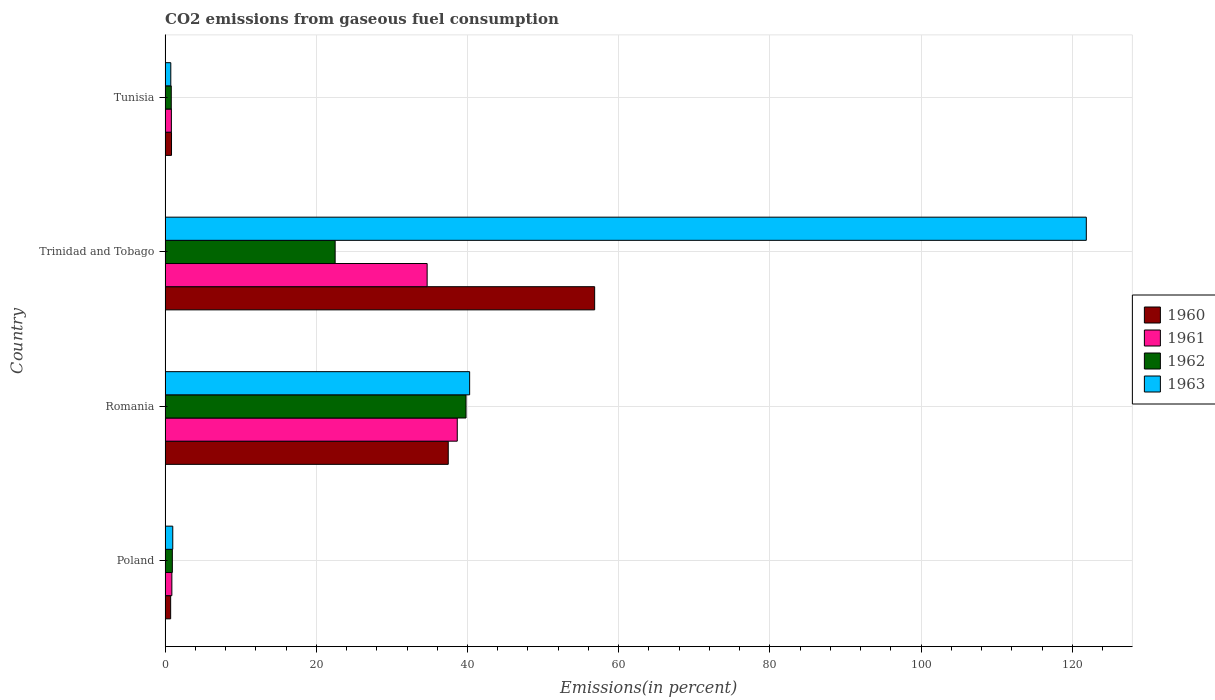How many groups of bars are there?
Your response must be concise. 4. Are the number of bars on each tick of the Y-axis equal?
Ensure brevity in your answer.  Yes. What is the label of the 2nd group of bars from the top?
Make the answer very short. Trinidad and Tobago. In how many cases, is the number of bars for a given country not equal to the number of legend labels?
Your answer should be compact. 0. What is the total CO2 emitted in 1961 in Poland?
Offer a very short reply. 0.89. Across all countries, what is the maximum total CO2 emitted in 1960?
Your response must be concise. 56.82. Across all countries, what is the minimum total CO2 emitted in 1960?
Your response must be concise. 0.74. In which country was the total CO2 emitted in 1960 maximum?
Your answer should be very brief. Trinidad and Tobago. In which country was the total CO2 emitted in 1962 minimum?
Give a very brief answer. Tunisia. What is the total total CO2 emitted in 1962 in the graph?
Offer a terse response. 64.07. What is the difference between the total CO2 emitted in 1963 in Poland and that in Romania?
Your response must be concise. -39.27. What is the difference between the total CO2 emitted in 1962 in Poland and the total CO2 emitted in 1960 in Trinidad and Tobago?
Provide a succinct answer. -55.86. What is the average total CO2 emitted in 1962 per country?
Give a very brief answer. 16.02. What is the difference between the total CO2 emitted in 1961 and total CO2 emitted in 1963 in Tunisia?
Give a very brief answer. 0.08. In how many countries, is the total CO2 emitted in 1962 greater than 92 %?
Provide a succinct answer. 0. What is the ratio of the total CO2 emitted in 1961 in Poland to that in Romania?
Provide a short and direct response. 0.02. Is the total CO2 emitted in 1962 in Poland less than that in Tunisia?
Provide a succinct answer. No. Is the difference between the total CO2 emitted in 1961 in Poland and Trinidad and Tobago greater than the difference between the total CO2 emitted in 1963 in Poland and Trinidad and Tobago?
Your answer should be very brief. Yes. What is the difference between the highest and the second highest total CO2 emitted in 1962?
Your answer should be compact. 17.31. What is the difference between the highest and the lowest total CO2 emitted in 1962?
Offer a very short reply. 38.99. In how many countries, is the total CO2 emitted in 1962 greater than the average total CO2 emitted in 1962 taken over all countries?
Your response must be concise. 2. Is it the case that in every country, the sum of the total CO2 emitted in 1962 and total CO2 emitted in 1963 is greater than the total CO2 emitted in 1960?
Ensure brevity in your answer.  Yes. How many bars are there?
Offer a terse response. 16. How many countries are there in the graph?
Offer a very short reply. 4. What is the difference between two consecutive major ticks on the X-axis?
Provide a succinct answer. 20. Does the graph contain grids?
Offer a very short reply. Yes. Where does the legend appear in the graph?
Give a very brief answer. Center right. How many legend labels are there?
Ensure brevity in your answer.  4. How are the legend labels stacked?
Make the answer very short. Vertical. What is the title of the graph?
Your response must be concise. CO2 emissions from gaseous fuel consumption. Does "2011" appear as one of the legend labels in the graph?
Provide a short and direct response. No. What is the label or title of the X-axis?
Keep it short and to the point. Emissions(in percent). What is the label or title of the Y-axis?
Provide a short and direct response. Country. What is the Emissions(in percent) of 1960 in Poland?
Your answer should be compact. 0.74. What is the Emissions(in percent) in 1961 in Poland?
Ensure brevity in your answer.  0.89. What is the Emissions(in percent) of 1962 in Poland?
Your answer should be very brief. 0.96. What is the Emissions(in percent) of 1963 in Poland?
Offer a very short reply. 1.01. What is the Emissions(in percent) in 1960 in Romania?
Provide a succinct answer. 37.45. What is the Emissions(in percent) of 1961 in Romania?
Make the answer very short. 38.65. What is the Emissions(in percent) in 1962 in Romania?
Make the answer very short. 39.8. What is the Emissions(in percent) of 1963 in Romania?
Make the answer very short. 40.28. What is the Emissions(in percent) in 1960 in Trinidad and Tobago?
Give a very brief answer. 56.82. What is the Emissions(in percent) of 1961 in Trinidad and Tobago?
Offer a very short reply. 34.66. What is the Emissions(in percent) in 1962 in Trinidad and Tobago?
Keep it short and to the point. 22.49. What is the Emissions(in percent) of 1963 in Trinidad and Tobago?
Keep it short and to the point. 121.85. What is the Emissions(in percent) of 1960 in Tunisia?
Provide a succinct answer. 0.85. What is the Emissions(in percent) of 1961 in Tunisia?
Offer a very short reply. 0.83. What is the Emissions(in percent) of 1962 in Tunisia?
Provide a succinct answer. 0.82. What is the Emissions(in percent) of 1963 in Tunisia?
Your answer should be compact. 0.75. Across all countries, what is the maximum Emissions(in percent) in 1960?
Your response must be concise. 56.82. Across all countries, what is the maximum Emissions(in percent) in 1961?
Make the answer very short. 38.65. Across all countries, what is the maximum Emissions(in percent) in 1962?
Offer a terse response. 39.8. Across all countries, what is the maximum Emissions(in percent) of 1963?
Your answer should be very brief. 121.85. Across all countries, what is the minimum Emissions(in percent) in 1960?
Your response must be concise. 0.74. Across all countries, what is the minimum Emissions(in percent) in 1961?
Ensure brevity in your answer.  0.83. Across all countries, what is the minimum Emissions(in percent) in 1962?
Keep it short and to the point. 0.82. Across all countries, what is the minimum Emissions(in percent) in 1963?
Ensure brevity in your answer.  0.75. What is the total Emissions(in percent) of 1960 in the graph?
Keep it short and to the point. 95.86. What is the total Emissions(in percent) of 1961 in the graph?
Ensure brevity in your answer.  75.03. What is the total Emissions(in percent) in 1962 in the graph?
Your response must be concise. 64.07. What is the total Emissions(in percent) in 1963 in the graph?
Provide a succinct answer. 163.9. What is the difference between the Emissions(in percent) in 1960 in Poland and that in Romania?
Keep it short and to the point. -36.72. What is the difference between the Emissions(in percent) in 1961 in Poland and that in Romania?
Offer a terse response. -37.75. What is the difference between the Emissions(in percent) of 1962 in Poland and that in Romania?
Provide a succinct answer. -38.85. What is the difference between the Emissions(in percent) in 1963 in Poland and that in Romania?
Your answer should be compact. -39.27. What is the difference between the Emissions(in percent) of 1960 in Poland and that in Trinidad and Tobago?
Your answer should be very brief. -56.08. What is the difference between the Emissions(in percent) of 1961 in Poland and that in Trinidad and Tobago?
Offer a terse response. -33.77. What is the difference between the Emissions(in percent) of 1962 in Poland and that in Trinidad and Tobago?
Keep it short and to the point. -21.53. What is the difference between the Emissions(in percent) of 1963 in Poland and that in Trinidad and Tobago?
Your answer should be compact. -120.84. What is the difference between the Emissions(in percent) of 1960 in Poland and that in Tunisia?
Provide a short and direct response. -0.11. What is the difference between the Emissions(in percent) of 1961 in Poland and that in Tunisia?
Give a very brief answer. 0.06. What is the difference between the Emissions(in percent) of 1962 in Poland and that in Tunisia?
Provide a short and direct response. 0.14. What is the difference between the Emissions(in percent) of 1963 in Poland and that in Tunisia?
Provide a succinct answer. 0.26. What is the difference between the Emissions(in percent) in 1960 in Romania and that in Trinidad and Tobago?
Your answer should be compact. -19.37. What is the difference between the Emissions(in percent) of 1961 in Romania and that in Trinidad and Tobago?
Give a very brief answer. 3.98. What is the difference between the Emissions(in percent) in 1962 in Romania and that in Trinidad and Tobago?
Ensure brevity in your answer.  17.31. What is the difference between the Emissions(in percent) in 1963 in Romania and that in Trinidad and Tobago?
Make the answer very short. -81.57. What is the difference between the Emissions(in percent) of 1960 in Romania and that in Tunisia?
Give a very brief answer. 36.6. What is the difference between the Emissions(in percent) of 1961 in Romania and that in Tunisia?
Provide a short and direct response. 37.82. What is the difference between the Emissions(in percent) of 1962 in Romania and that in Tunisia?
Offer a very short reply. 38.99. What is the difference between the Emissions(in percent) in 1963 in Romania and that in Tunisia?
Your answer should be compact. 39.53. What is the difference between the Emissions(in percent) of 1960 in Trinidad and Tobago and that in Tunisia?
Your answer should be compact. 55.97. What is the difference between the Emissions(in percent) in 1961 in Trinidad and Tobago and that in Tunisia?
Ensure brevity in your answer.  33.83. What is the difference between the Emissions(in percent) of 1962 in Trinidad and Tobago and that in Tunisia?
Your response must be concise. 21.68. What is the difference between the Emissions(in percent) of 1963 in Trinidad and Tobago and that in Tunisia?
Your answer should be compact. 121.1. What is the difference between the Emissions(in percent) of 1960 in Poland and the Emissions(in percent) of 1961 in Romania?
Keep it short and to the point. -37.91. What is the difference between the Emissions(in percent) of 1960 in Poland and the Emissions(in percent) of 1962 in Romania?
Your answer should be very brief. -39.07. What is the difference between the Emissions(in percent) of 1960 in Poland and the Emissions(in percent) of 1963 in Romania?
Offer a very short reply. -39.55. What is the difference between the Emissions(in percent) in 1961 in Poland and the Emissions(in percent) in 1962 in Romania?
Keep it short and to the point. -38.91. What is the difference between the Emissions(in percent) of 1961 in Poland and the Emissions(in percent) of 1963 in Romania?
Your answer should be compact. -39.39. What is the difference between the Emissions(in percent) of 1962 in Poland and the Emissions(in percent) of 1963 in Romania?
Your answer should be compact. -39.32. What is the difference between the Emissions(in percent) in 1960 in Poland and the Emissions(in percent) in 1961 in Trinidad and Tobago?
Make the answer very short. -33.93. What is the difference between the Emissions(in percent) of 1960 in Poland and the Emissions(in percent) of 1962 in Trinidad and Tobago?
Give a very brief answer. -21.76. What is the difference between the Emissions(in percent) of 1960 in Poland and the Emissions(in percent) of 1963 in Trinidad and Tobago?
Give a very brief answer. -121.11. What is the difference between the Emissions(in percent) of 1961 in Poland and the Emissions(in percent) of 1962 in Trinidad and Tobago?
Offer a terse response. -21.6. What is the difference between the Emissions(in percent) of 1961 in Poland and the Emissions(in percent) of 1963 in Trinidad and Tobago?
Your answer should be compact. -120.95. What is the difference between the Emissions(in percent) of 1962 in Poland and the Emissions(in percent) of 1963 in Trinidad and Tobago?
Offer a very short reply. -120.89. What is the difference between the Emissions(in percent) of 1960 in Poland and the Emissions(in percent) of 1961 in Tunisia?
Offer a very short reply. -0.09. What is the difference between the Emissions(in percent) of 1960 in Poland and the Emissions(in percent) of 1962 in Tunisia?
Offer a terse response. -0.08. What is the difference between the Emissions(in percent) in 1960 in Poland and the Emissions(in percent) in 1963 in Tunisia?
Ensure brevity in your answer.  -0.02. What is the difference between the Emissions(in percent) of 1961 in Poland and the Emissions(in percent) of 1962 in Tunisia?
Make the answer very short. 0.08. What is the difference between the Emissions(in percent) in 1961 in Poland and the Emissions(in percent) in 1963 in Tunisia?
Keep it short and to the point. 0.14. What is the difference between the Emissions(in percent) of 1962 in Poland and the Emissions(in percent) of 1963 in Tunisia?
Your response must be concise. 0.21. What is the difference between the Emissions(in percent) in 1960 in Romania and the Emissions(in percent) in 1961 in Trinidad and Tobago?
Offer a very short reply. 2.79. What is the difference between the Emissions(in percent) of 1960 in Romania and the Emissions(in percent) of 1962 in Trinidad and Tobago?
Provide a short and direct response. 14.96. What is the difference between the Emissions(in percent) of 1960 in Romania and the Emissions(in percent) of 1963 in Trinidad and Tobago?
Your answer should be compact. -84.4. What is the difference between the Emissions(in percent) in 1961 in Romania and the Emissions(in percent) in 1962 in Trinidad and Tobago?
Your answer should be compact. 16.15. What is the difference between the Emissions(in percent) of 1961 in Romania and the Emissions(in percent) of 1963 in Trinidad and Tobago?
Make the answer very short. -83.2. What is the difference between the Emissions(in percent) in 1962 in Romania and the Emissions(in percent) in 1963 in Trinidad and Tobago?
Provide a short and direct response. -82.04. What is the difference between the Emissions(in percent) of 1960 in Romania and the Emissions(in percent) of 1961 in Tunisia?
Your answer should be compact. 36.62. What is the difference between the Emissions(in percent) of 1960 in Romania and the Emissions(in percent) of 1962 in Tunisia?
Offer a terse response. 36.64. What is the difference between the Emissions(in percent) of 1960 in Romania and the Emissions(in percent) of 1963 in Tunisia?
Ensure brevity in your answer.  36.7. What is the difference between the Emissions(in percent) of 1961 in Romania and the Emissions(in percent) of 1962 in Tunisia?
Offer a very short reply. 37.83. What is the difference between the Emissions(in percent) in 1961 in Romania and the Emissions(in percent) in 1963 in Tunisia?
Provide a succinct answer. 37.89. What is the difference between the Emissions(in percent) in 1962 in Romania and the Emissions(in percent) in 1963 in Tunisia?
Your response must be concise. 39.05. What is the difference between the Emissions(in percent) of 1960 in Trinidad and Tobago and the Emissions(in percent) of 1961 in Tunisia?
Offer a very short reply. 55.99. What is the difference between the Emissions(in percent) in 1960 in Trinidad and Tobago and the Emissions(in percent) in 1962 in Tunisia?
Your response must be concise. 56. What is the difference between the Emissions(in percent) of 1960 in Trinidad and Tobago and the Emissions(in percent) of 1963 in Tunisia?
Offer a terse response. 56.06. What is the difference between the Emissions(in percent) in 1961 in Trinidad and Tobago and the Emissions(in percent) in 1962 in Tunisia?
Your answer should be compact. 33.84. What is the difference between the Emissions(in percent) in 1961 in Trinidad and Tobago and the Emissions(in percent) in 1963 in Tunisia?
Your response must be concise. 33.91. What is the difference between the Emissions(in percent) in 1962 in Trinidad and Tobago and the Emissions(in percent) in 1963 in Tunisia?
Your response must be concise. 21.74. What is the average Emissions(in percent) of 1960 per country?
Make the answer very short. 23.96. What is the average Emissions(in percent) of 1961 per country?
Provide a succinct answer. 18.76. What is the average Emissions(in percent) of 1962 per country?
Make the answer very short. 16.02. What is the average Emissions(in percent) in 1963 per country?
Provide a succinct answer. 40.97. What is the difference between the Emissions(in percent) of 1960 and Emissions(in percent) of 1961 in Poland?
Your answer should be compact. -0.16. What is the difference between the Emissions(in percent) in 1960 and Emissions(in percent) in 1962 in Poland?
Your answer should be compact. -0.22. What is the difference between the Emissions(in percent) in 1960 and Emissions(in percent) in 1963 in Poland?
Offer a very short reply. -0.28. What is the difference between the Emissions(in percent) in 1961 and Emissions(in percent) in 1962 in Poland?
Offer a very short reply. -0.06. What is the difference between the Emissions(in percent) in 1961 and Emissions(in percent) in 1963 in Poland?
Offer a terse response. -0.12. What is the difference between the Emissions(in percent) of 1962 and Emissions(in percent) of 1963 in Poland?
Give a very brief answer. -0.05. What is the difference between the Emissions(in percent) in 1960 and Emissions(in percent) in 1961 in Romania?
Keep it short and to the point. -1.19. What is the difference between the Emissions(in percent) of 1960 and Emissions(in percent) of 1962 in Romania?
Give a very brief answer. -2.35. What is the difference between the Emissions(in percent) in 1960 and Emissions(in percent) in 1963 in Romania?
Give a very brief answer. -2.83. What is the difference between the Emissions(in percent) in 1961 and Emissions(in percent) in 1962 in Romania?
Provide a succinct answer. -1.16. What is the difference between the Emissions(in percent) of 1961 and Emissions(in percent) of 1963 in Romania?
Your answer should be very brief. -1.64. What is the difference between the Emissions(in percent) of 1962 and Emissions(in percent) of 1963 in Romania?
Offer a very short reply. -0.48. What is the difference between the Emissions(in percent) in 1960 and Emissions(in percent) in 1961 in Trinidad and Tobago?
Provide a succinct answer. 22.16. What is the difference between the Emissions(in percent) of 1960 and Emissions(in percent) of 1962 in Trinidad and Tobago?
Your answer should be very brief. 34.33. What is the difference between the Emissions(in percent) in 1960 and Emissions(in percent) in 1963 in Trinidad and Tobago?
Provide a succinct answer. -65.03. What is the difference between the Emissions(in percent) in 1961 and Emissions(in percent) in 1962 in Trinidad and Tobago?
Your answer should be very brief. 12.17. What is the difference between the Emissions(in percent) in 1961 and Emissions(in percent) in 1963 in Trinidad and Tobago?
Make the answer very short. -87.19. What is the difference between the Emissions(in percent) in 1962 and Emissions(in percent) in 1963 in Trinidad and Tobago?
Make the answer very short. -99.36. What is the difference between the Emissions(in percent) of 1960 and Emissions(in percent) of 1961 in Tunisia?
Your response must be concise. 0.02. What is the difference between the Emissions(in percent) in 1960 and Emissions(in percent) in 1962 in Tunisia?
Offer a terse response. 0.03. What is the difference between the Emissions(in percent) in 1960 and Emissions(in percent) in 1963 in Tunisia?
Provide a succinct answer. 0.1. What is the difference between the Emissions(in percent) in 1961 and Emissions(in percent) in 1962 in Tunisia?
Provide a short and direct response. 0.01. What is the difference between the Emissions(in percent) in 1961 and Emissions(in percent) in 1963 in Tunisia?
Offer a terse response. 0.08. What is the difference between the Emissions(in percent) in 1962 and Emissions(in percent) in 1963 in Tunisia?
Make the answer very short. 0.06. What is the ratio of the Emissions(in percent) of 1960 in Poland to that in Romania?
Your answer should be compact. 0.02. What is the ratio of the Emissions(in percent) in 1961 in Poland to that in Romania?
Your answer should be very brief. 0.02. What is the ratio of the Emissions(in percent) of 1962 in Poland to that in Romania?
Give a very brief answer. 0.02. What is the ratio of the Emissions(in percent) of 1963 in Poland to that in Romania?
Offer a very short reply. 0.03. What is the ratio of the Emissions(in percent) of 1960 in Poland to that in Trinidad and Tobago?
Provide a short and direct response. 0.01. What is the ratio of the Emissions(in percent) in 1961 in Poland to that in Trinidad and Tobago?
Provide a succinct answer. 0.03. What is the ratio of the Emissions(in percent) in 1962 in Poland to that in Trinidad and Tobago?
Keep it short and to the point. 0.04. What is the ratio of the Emissions(in percent) of 1963 in Poland to that in Trinidad and Tobago?
Make the answer very short. 0.01. What is the ratio of the Emissions(in percent) of 1960 in Poland to that in Tunisia?
Provide a short and direct response. 0.87. What is the ratio of the Emissions(in percent) of 1961 in Poland to that in Tunisia?
Make the answer very short. 1.08. What is the ratio of the Emissions(in percent) in 1962 in Poland to that in Tunisia?
Give a very brief answer. 1.17. What is the ratio of the Emissions(in percent) of 1963 in Poland to that in Tunisia?
Ensure brevity in your answer.  1.35. What is the ratio of the Emissions(in percent) of 1960 in Romania to that in Trinidad and Tobago?
Give a very brief answer. 0.66. What is the ratio of the Emissions(in percent) in 1961 in Romania to that in Trinidad and Tobago?
Keep it short and to the point. 1.11. What is the ratio of the Emissions(in percent) of 1962 in Romania to that in Trinidad and Tobago?
Ensure brevity in your answer.  1.77. What is the ratio of the Emissions(in percent) of 1963 in Romania to that in Trinidad and Tobago?
Offer a very short reply. 0.33. What is the ratio of the Emissions(in percent) in 1960 in Romania to that in Tunisia?
Make the answer very short. 44.1. What is the ratio of the Emissions(in percent) of 1961 in Romania to that in Tunisia?
Give a very brief answer. 46.57. What is the ratio of the Emissions(in percent) in 1962 in Romania to that in Tunisia?
Your response must be concise. 48.76. What is the ratio of the Emissions(in percent) of 1963 in Romania to that in Tunisia?
Your answer should be very brief. 53.48. What is the ratio of the Emissions(in percent) in 1960 in Trinidad and Tobago to that in Tunisia?
Give a very brief answer. 66.9. What is the ratio of the Emissions(in percent) of 1961 in Trinidad and Tobago to that in Tunisia?
Offer a terse response. 41.77. What is the ratio of the Emissions(in percent) in 1962 in Trinidad and Tobago to that in Tunisia?
Offer a very short reply. 27.55. What is the ratio of the Emissions(in percent) of 1963 in Trinidad and Tobago to that in Tunisia?
Make the answer very short. 161.75. What is the difference between the highest and the second highest Emissions(in percent) in 1960?
Your response must be concise. 19.37. What is the difference between the highest and the second highest Emissions(in percent) in 1961?
Offer a terse response. 3.98. What is the difference between the highest and the second highest Emissions(in percent) of 1962?
Offer a terse response. 17.31. What is the difference between the highest and the second highest Emissions(in percent) in 1963?
Offer a very short reply. 81.57. What is the difference between the highest and the lowest Emissions(in percent) of 1960?
Offer a terse response. 56.08. What is the difference between the highest and the lowest Emissions(in percent) of 1961?
Provide a short and direct response. 37.82. What is the difference between the highest and the lowest Emissions(in percent) in 1962?
Make the answer very short. 38.99. What is the difference between the highest and the lowest Emissions(in percent) in 1963?
Provide a short and direct response. 121.1. 